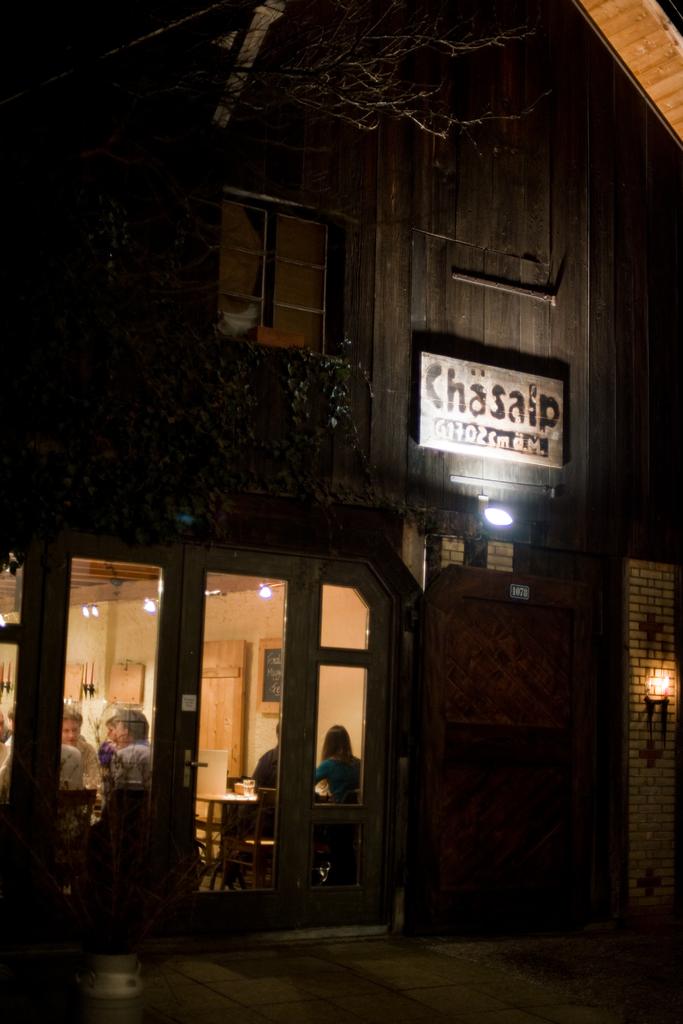What is the name of this shop?
Make the answer very short. Chasaip. 